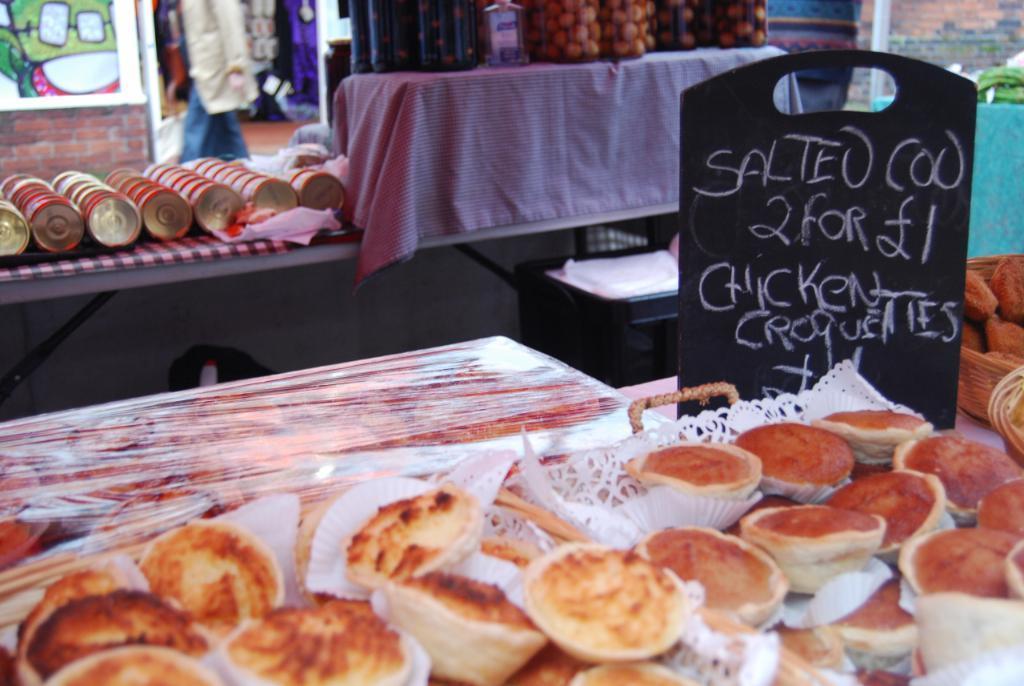Can you describe this image briefly? In this image at the bottom there are food items in plastic covers, on the right side there is a board in black color which indicates the price of these things. On the left side there are circular things on this table, there is a wall. At the top there are glass jars in this image. 